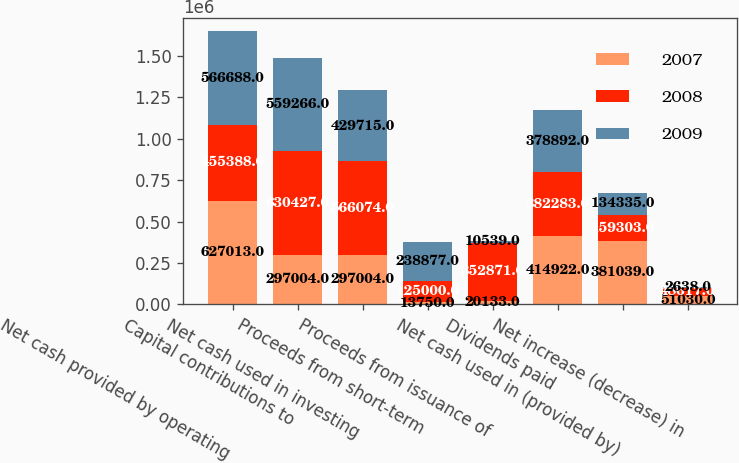Convert chart to OTSL. <chart><loc_0><loc_0><loc_500><loc_500><stacked_bar_chart><ecel><fcel>Net cash provided by operating<fcel>Capital contributions to<fcel>Net cash used in investing<fcel>Proceeds from short-term<fcel>Proceeds from issuance of<fcel>Dividends paid<fcel>Net cash used in (provided by)<fcel>Net increase (decrease) in<nl><fcel>2007<fcel>627013<fcel>297004<fcel>297004<fcel>13750<fcel>20133<fcel>414922<fcel>381039<fcel>51030<nl><fcel>2008<fcel>455388<fcel>630427<fcel>566074<fcel>125000<fcel>352871<fcel>382283<fcel>159303<fcel>48617<nl><fcel>2009<fcel>566688<fcel>559266<fcel>429715<fcel>238877<fcel>10539<fcel>378892<fcel>134335<fcel>2638<nl></chart> 